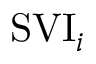Convert formula to latex. <formula><loc_0><loc_0><loc_500><loc_500>S V I _ { i }</formula> 